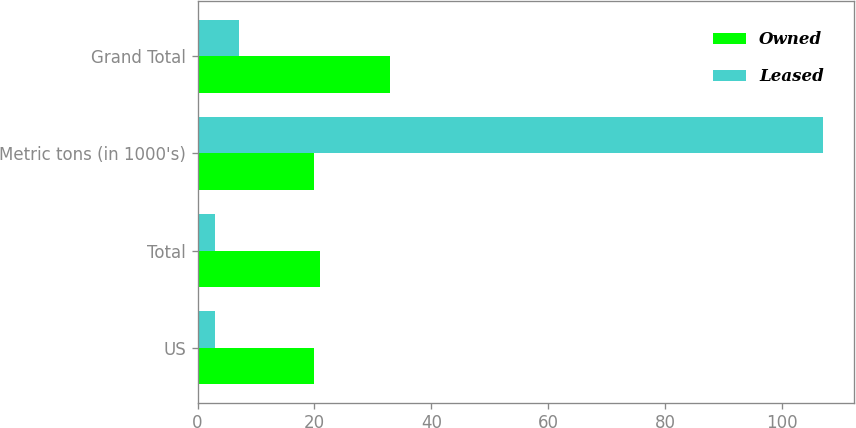<chart> <loc_0><loc_0><loc_500><loc_500><stacked_bar_chart><ecel><fcel>US<fcel>Total<fcel>Metric tons (in 1000's)<fcel>Grand Total<nl><fcel>Owned<fcel>20<fcel>21<fcel>20<fcel>33<nl><fcel>Leased<fcel>3<fcel>3<fcel>107<fcel>7<nl></chart> 